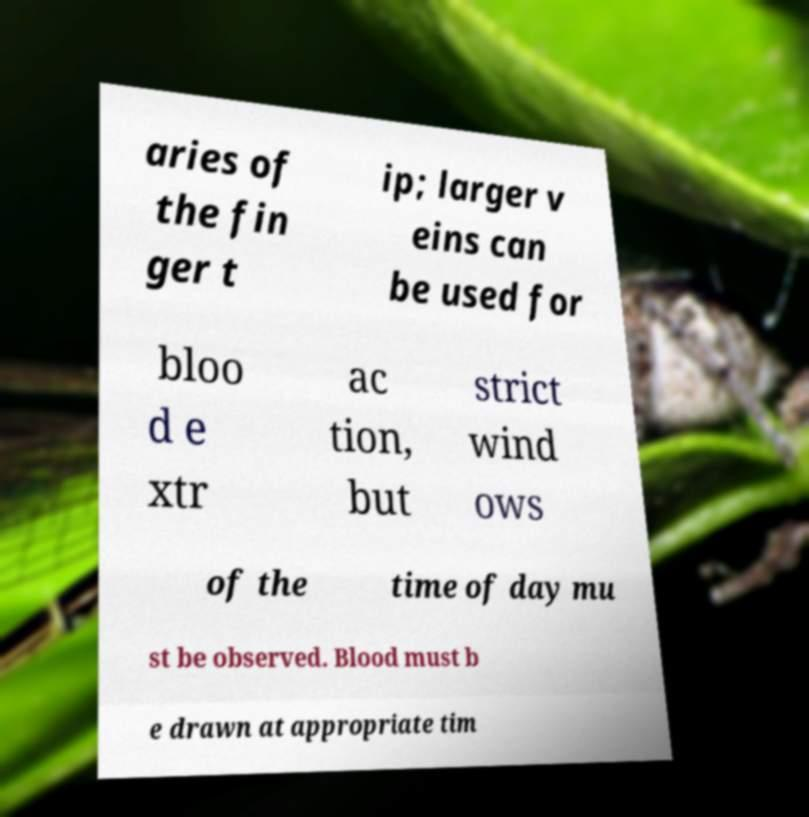Please read and relay the text visible in this image. What does it say? aries of the fin ger t ip; larger v eins can be used for bloo d e xtr ac tion, but strict wind ows of the time of day mu st be observed. Blood must b e drawn at appropriate tim 